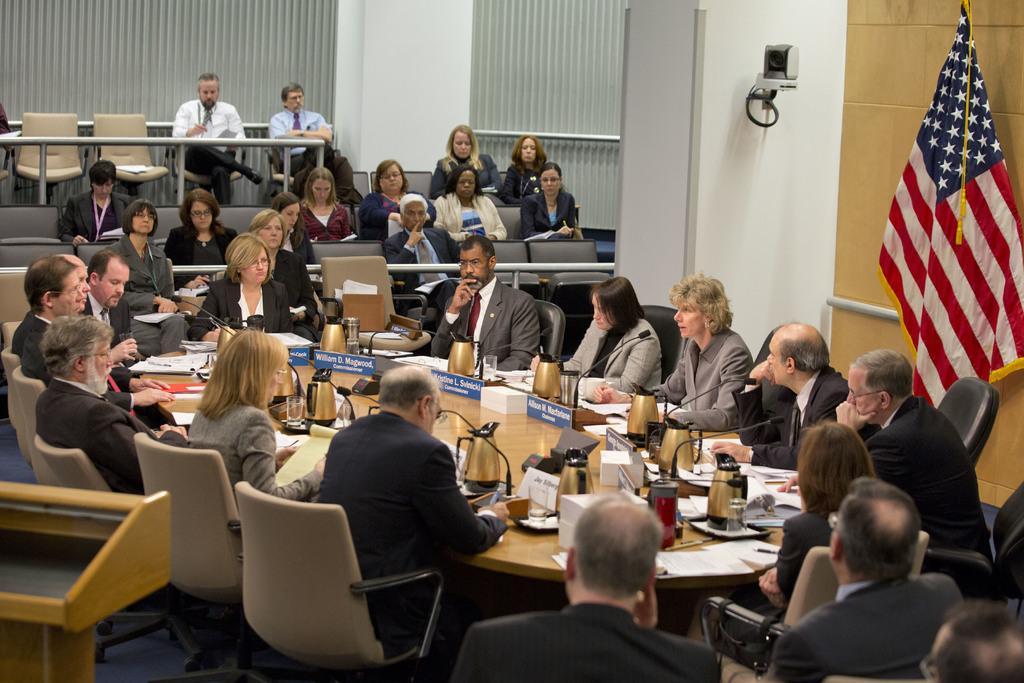In one or two sentences, can you explain what this image depicts? There are group of people in image. In which we can see people are sitting on their chairs. Here there is a table on which we can see jar,water bottle,paper,microphone,name board,books,pen. On right side of wall we can see a camera and a flag. In the middle there is a woman who is wearing glasses and sitting on chair. 